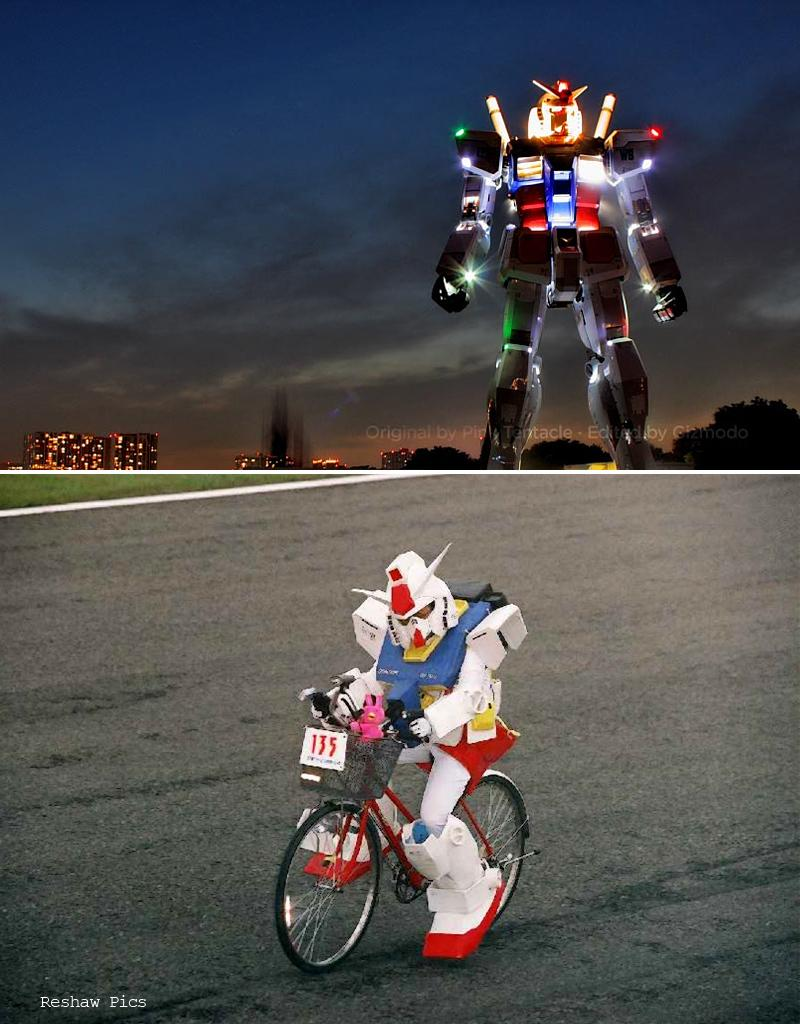What type of artwork is the image? The image is a collage. What can be seen in the collage? There are two robots in the image. What else is featured in the collage besides the robots? There is a road in the image. Where is the stove located in the image? There is no stove present in the image. What type of error can be seen in the image? There is no error present in the image; it is a collage featuring two robots and a road. 